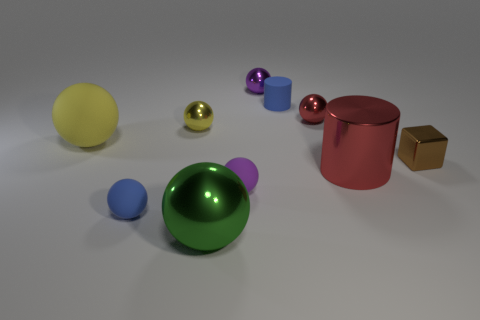What number of tiny brown things have the same shape as the green object?
Your answer should be very brief. 0. What size is the metal ball to the right of the purple sphere that is behind the large yellow ball?
Give a very brief answer. Small. There is a big ball that is in front of the small brown block; does it have the same color as the small rubber object that is behind the small red shiny thing?
Ensure brevity in your answer.  No. How many small red metal balls are to the left of the large sphere that is to the left of the blue thing in front of the brown metal cube?
Make the answer very short. 0. What number of tiny things are to the right of the small blue sphere and in front of the yellow metallic object?
Your answer should be compact. 2. Are there more brown things behind the brown cube than large cylinders?
Your answer should be very brief. No. How many cyan matte cylinders have the same size as the green thing?
Provide a short and direct response. 0. There is a thing that is the same color as the small cylinder; what size is it?
Your answer should be very brief. Small. How many tiny things are red metal cylinders or brown matte spheres?
Give a very brief answer. 0. How many small blue balls are there?
Make the answer very short. 1. 